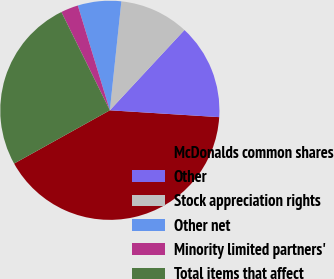Convert chart. <chart><loc_0><loc_0><loc_500><loc_500><pie_chart><fcel>McDonalds common shares<fcel>Other<fcel>Stock appreciation rights<fcel>Other net<fcel>Minority limited partners'<fcel>Total items that affect<nl><fcel>40.93%<fcel>14.08%<fcel>10.24%<fcel>6.4%<fcel>2.57%<fcel>25.79%<nl></chart> 